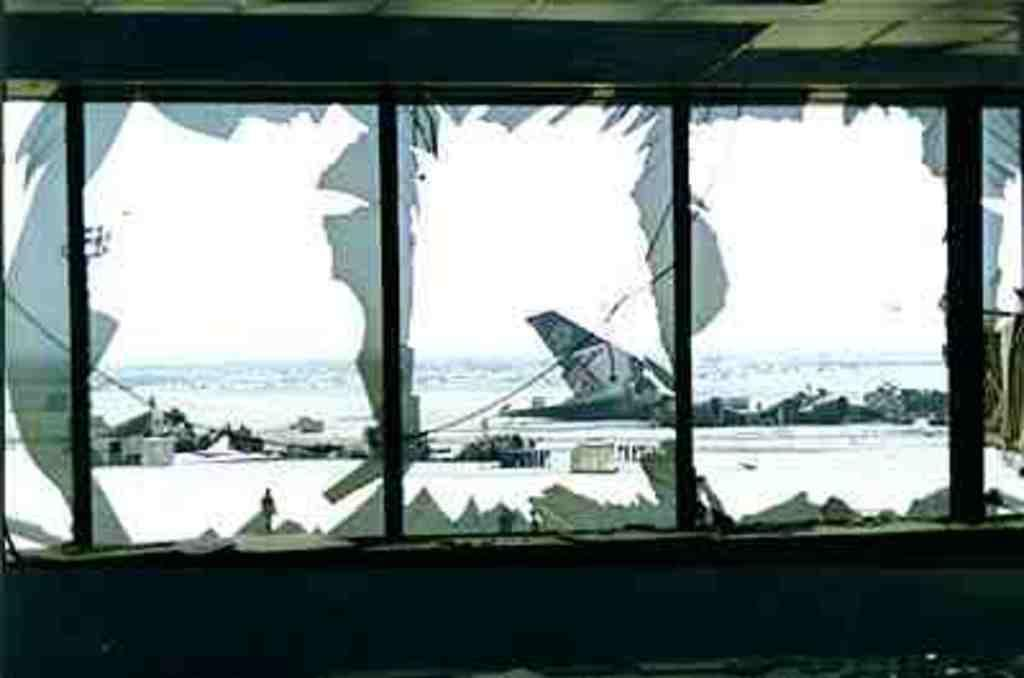What type of structure is in the center of the image? There are glass windows and a roof in the center of the image. What can be seen through the glass windows? The sky, clouds, water, and boats are visible through the glass windows. Are there any other objects visible through the glass windows? Yes, there are other objects visible through the glass windows. What type of curve can be seen on the mask in the image? There is no mask present in the image, so it is not possible to answer that question. 